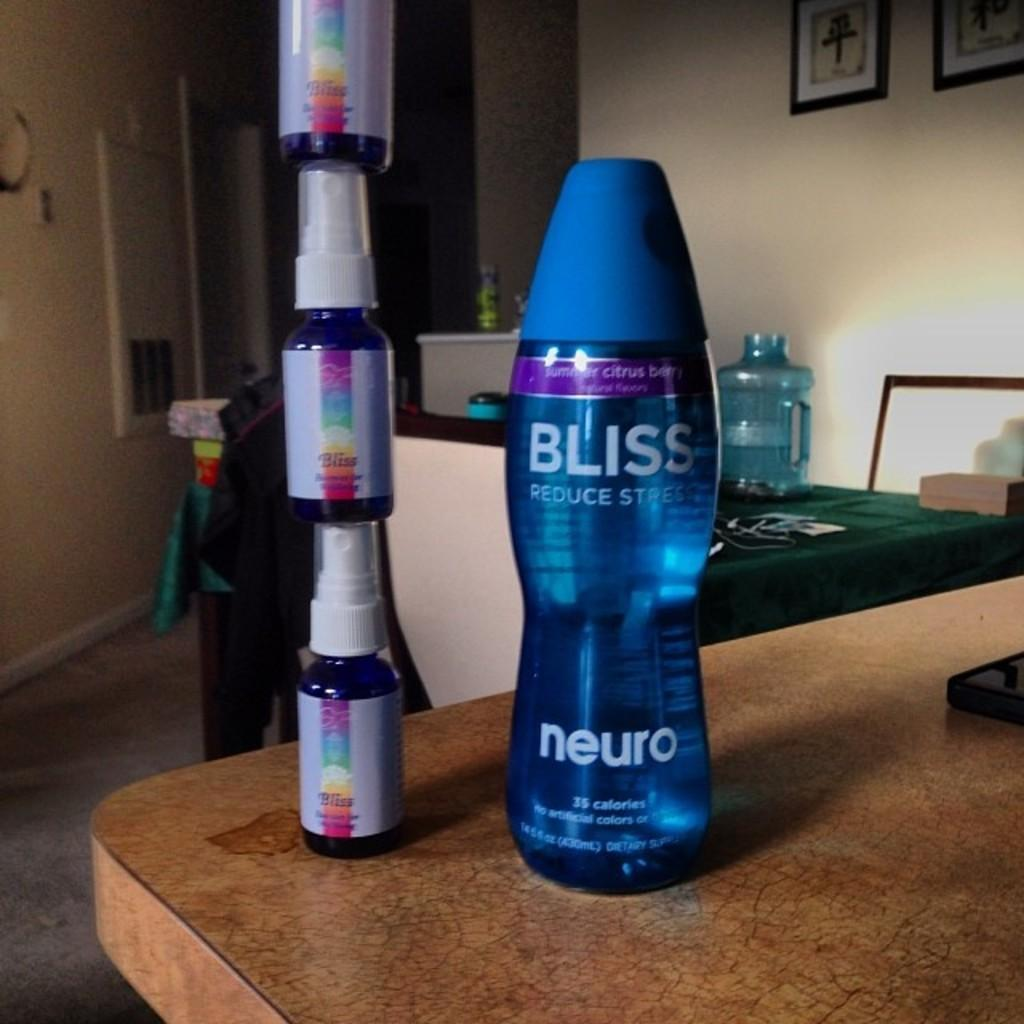<image>
Write a terse but informative summary of the picture. A bottle of Bliss neuro citrus berry flavored water next to a stack of Bliss spray bottles. 